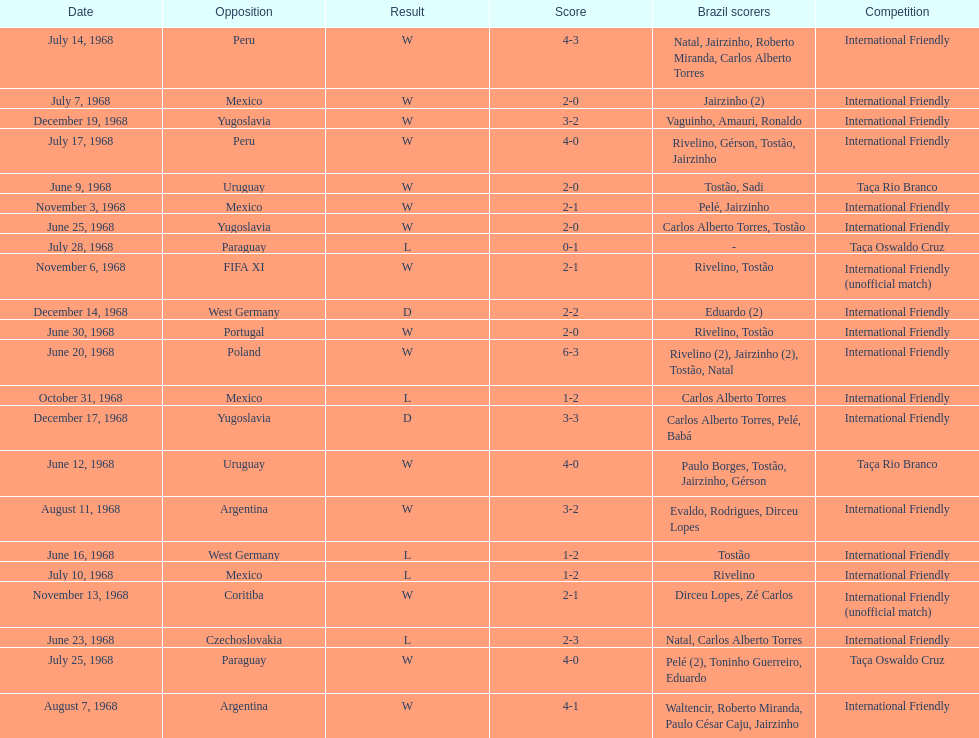Total number of wins 15. 